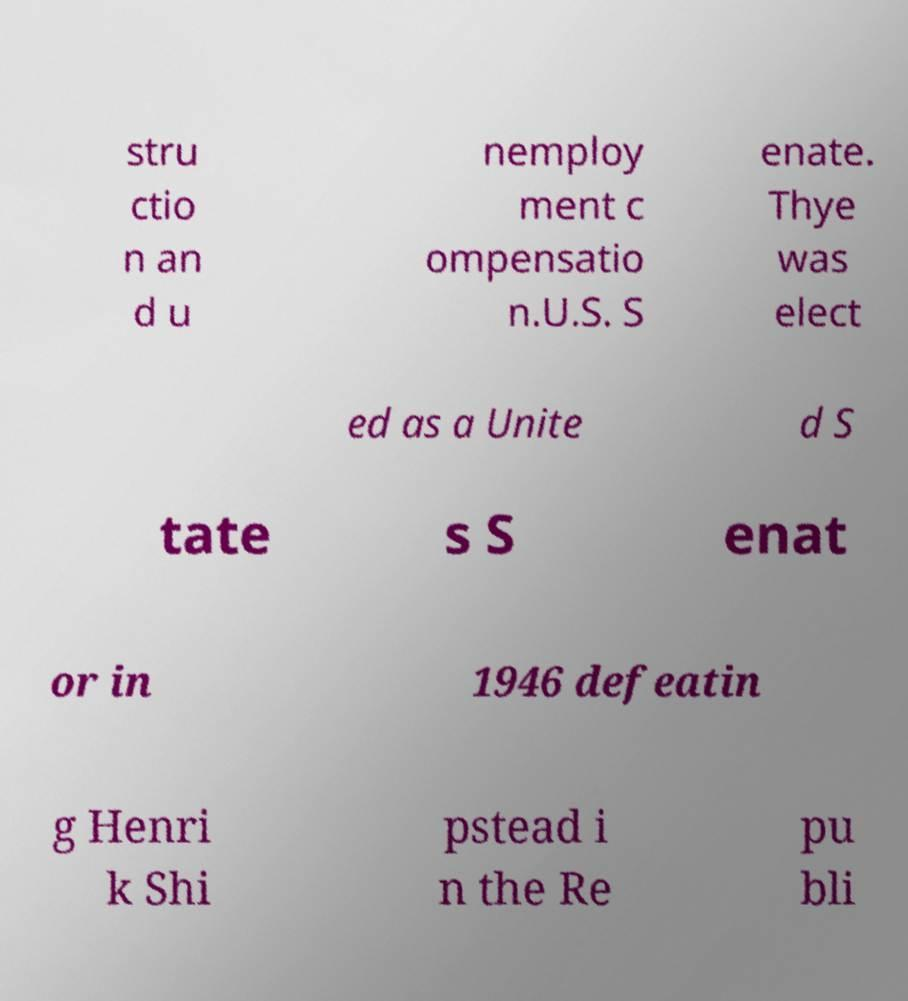What messages or text are displayed in this image? I need them in a readable, typed format. stru ctio n an d u nemploy ment c ompensatio n.U.S. S enate. Thye was elect ed as a Unite d S tate s S enat or in 1946 defeatin g Henri k Shi pstead i n the Re pu bli 